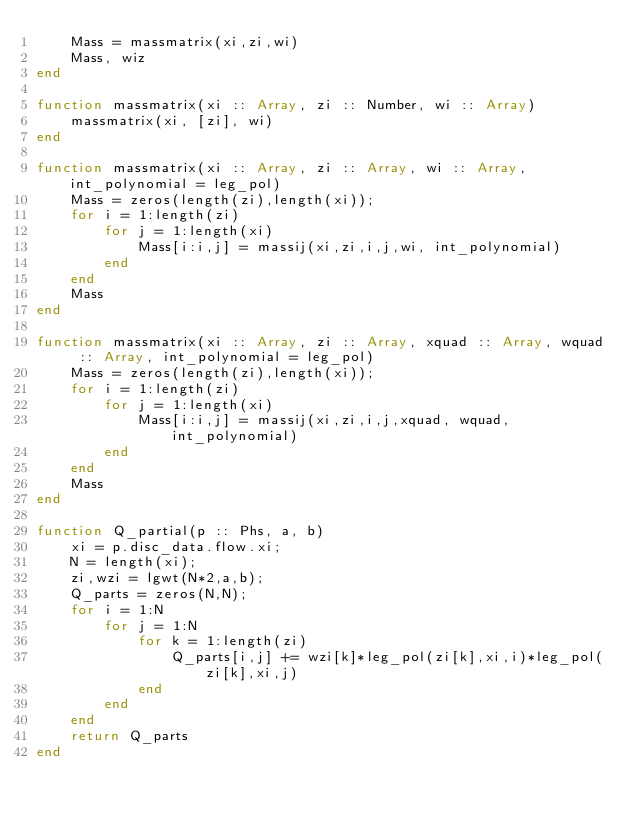Convert code to text. <code><loc_0><loc_0><loc_500><loc_500><_Julia_>	Mass = massmatrix(xi,zi,wi)
	Mass, wiz
end

function massmatrix(xi :: Array, zi :: Number, wi :: Array)
	massmatrix(xi, [zi], wi)
end

function massmatrix(xi :: Array, zi :: Array, wi :: Array, int_polynomial = leg_pol)
	Mass = zeros(length(zi),length(xi));
	for i = 1:length(zi)
		for j = 1:length(xi)
			Mass[i:i,j] = massij(xi,zi,i,j,wi, int_polynomial)
		end
	end
	Mass
end

function massmatrix(xi :: Array, zi :: Array, xquad :: Array, wquad :: Array, int_polynomial = leg_pol)
	Mass = zeros(length(zi),length(xi));
	for i = 1:length(zi)
		for j = 1:length(xi)
			Mass[i:i,j] = massij(xi,zi,i,j,xquad, wquad, int_polynomial)
		end
	end
	Mass
end

function Q_partial(p :: Phs, a, b)
	xi = p.disc_data.flow.xi;
	N = length(xi);
	zi,wzi = lgwt(N*2,a,b);
	Q_parts = zeros(N,N);
	for i = 1:N
		for j = 1:N
			for k = 1:length(zi)
				Q_parts[i,j] += wzi[k]*leg_pol(zi[k],xi,i)*leg_pol(zi[k],xi,j)
			end
		end
	end
	return Q_parts
end</code> 